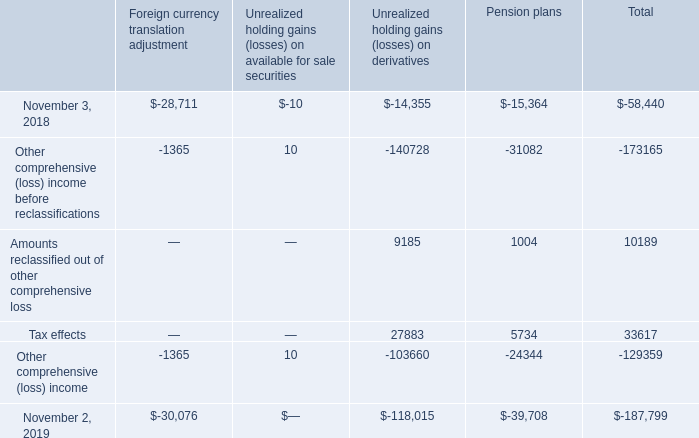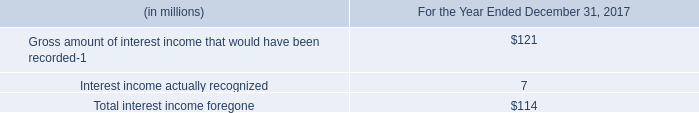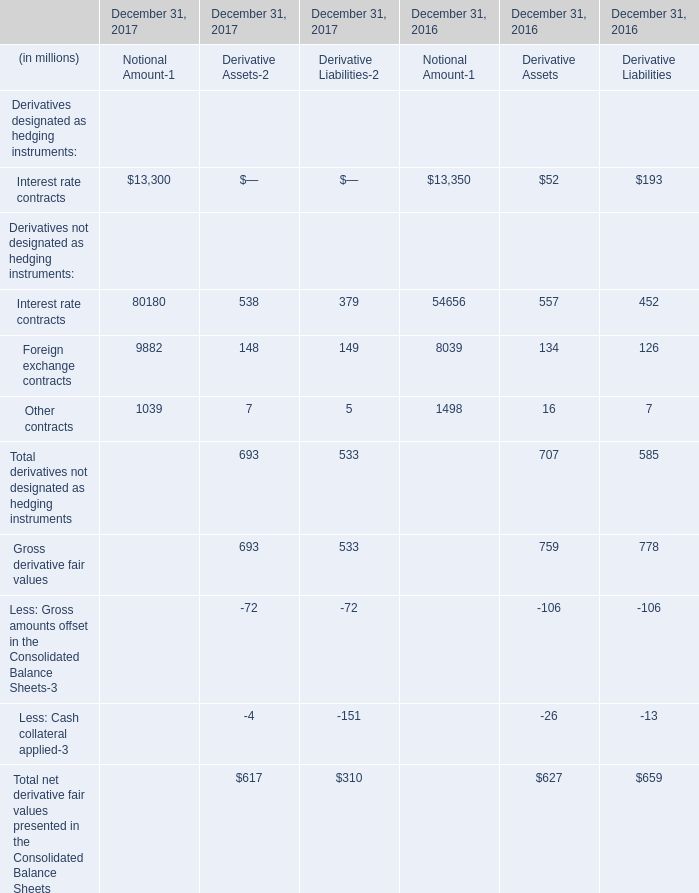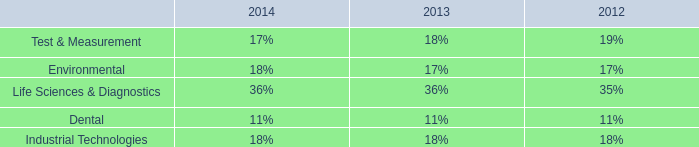In the year with largest amount of Interest rate contracts, what's the increasing rate of Other contracts? 
Computations: ((((1039 + 7) + 5) - ((1498 + 16) + 7)) / ((1498 + 16) + 7))
Answer: -0.30901. 